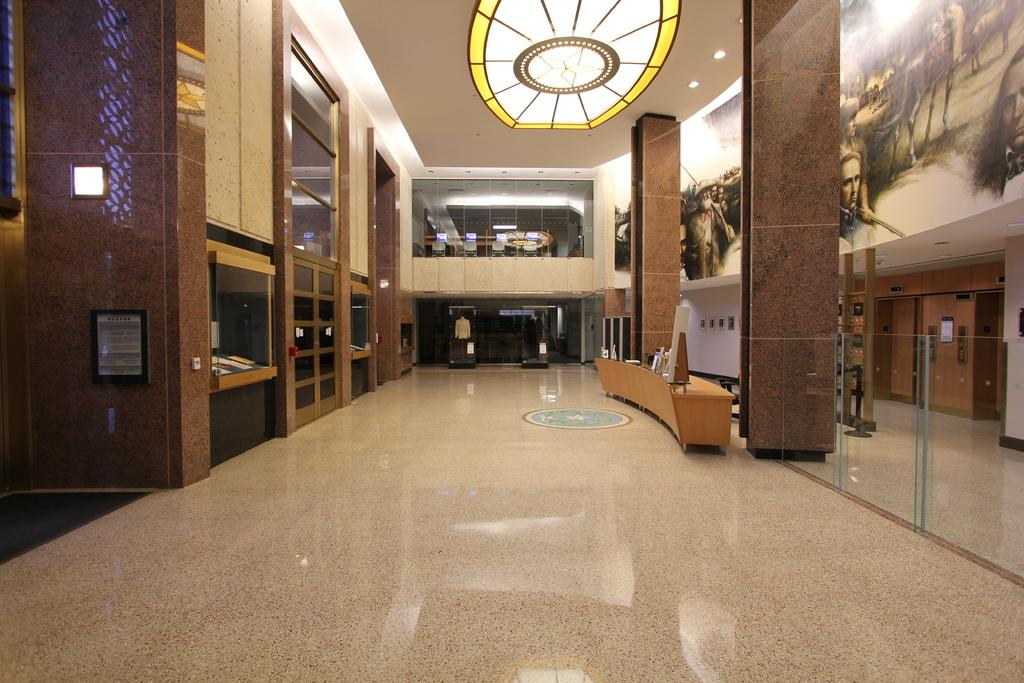Where was the image taken? The image was taken in a hall. What can be seen on the right side of the image? There is a table on the right side of the image. What is the source of light in the image? There is light at the top of the image. What is located on the left side of the image? There is a shelf on the left side of the image. What type of pie is being served on the table in the image? There is no pie present in the image; it only shows a table and a shelf. Can you see the partner of the person taking the photo in the image? There is no person taking the photo in the image, so it's not possible to see their partner. 